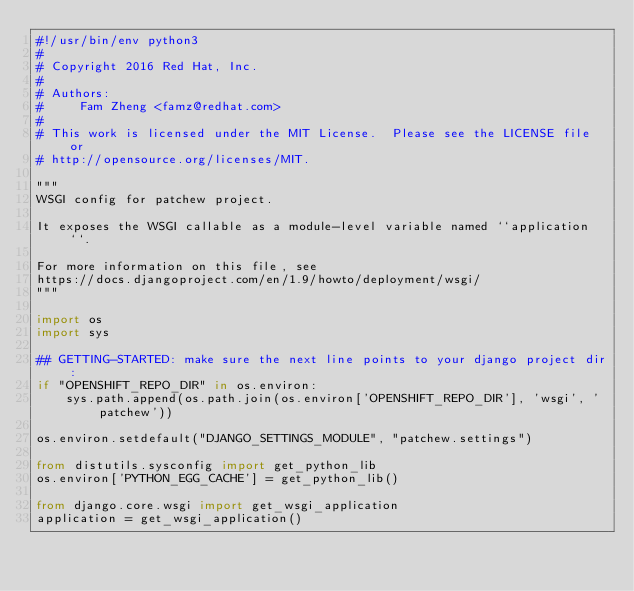<code> <loc_0><loc_0><loc_500><loc_500><_Python_>#!/usr/bin/env python3
#
# Copyright 2016 Red Hat, Inc.
#
# Authors:
#     Fam Zheng <famz@redhat.com>
#
# This work is licensed under the MIT License.  Please see the LICENSE file or
# http://opensource.org/licenses/MIT.

"""
WSGI config for patchew project.

It exposes the WSGI callable as a module-level variable named ``application``.

For more information on this file, see
https://docs.djangoproject.com/en/1.9/howto/deployment/wsgi/
"""

import os
import sys

## GETTING-STARTED: make sure the next line points to your django project dir:
if "OPENSHIFT_REPO_DIR" in os.environ:
    sys.path.append(os.path.join(os.environ['OPENSHIFT_REPO_DIR'], 'wsgi', 'patchew'))

os.environ.setdefault("DJANGO_SETTINGS_MODULE", "patchew.settings")

from distutils.sysconfig import get_python_lib
os.environ['PYTHON_EGG_CACHE'] = get_python_lib()

from django.core.wsgi import get_wsgi_application
application = get_wsgi_application()
</code> 